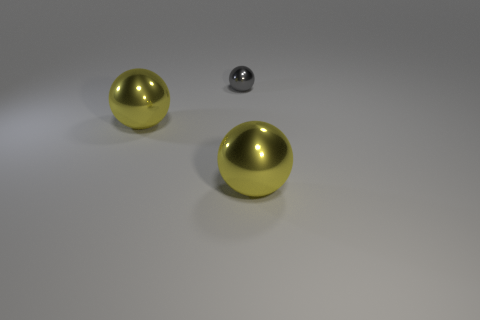There is a big metallic object that is right of the small shiny sphere; does it have the same shape as the shiny thing left of the tiny gray sphere?
Ensure brevity in your answer.  Yes. Is there a large ball made of the same material as the tiny gray thing?
Offer a very short reply. Yes. How many blue things are large objects or metallic spheres?
Your response must be concise. 0. Is the number of large metal objects on the right side of the gray metal object greater than the number of small metal balls?
Keep it short and to the point. No. What number of cylinders are yellow objects or small gray things?
Give a very brief answer. 0. How many objects are gray things or large yellow balls?
Provide a short and direct response. 3. How many objects are either large yellow things that are to the left of the tiny shiny thing or shiny things that are on the left side of the tiny gray metallic sphere?
Your answer should be compact. 1. Are there an equal number of yellow metallic balls to the right of the tiny object and small brown rubber cylinders?
Your answer should be compact. No. Is the size of the object right of the gray metallic sphere the same as the object that is on the left side of the small gray ball?
Offer a terse response. Yes. How many other objects are the same size as the gray thing?
Your answer should be compact. 0. 